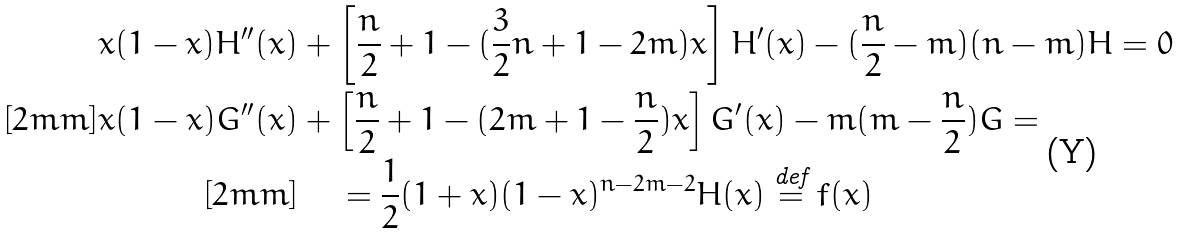Convert formula to latex. <formula><loc_0><loc_0><loc_500><loc_500>x ( 1 - x ) H ^ { \prime \prime } ( x ) & + \left [ \frac { n } { 2 } + 1 - ( \frac { 3 } { 2 } n + 1 - 2 m ) x \right ] H ^ { \prime } ( x ) - ( \frac { n } { 2 } - m ) ( n - m ) H = 0 \\ [ 2 m m ] x ( 1 - x ) G ^ { \prime \prime } ( x ) & + \left [ \frac { n } { 2 } + 1 - ( 2 m + 1 - \frac { n } { 2 } ) x \right ] G ^ { \prime } ( x ) - m ( m - \frac { n } { 2 } ) G = \\ [ 2 m m ] & \quad = \frac { 1 } { 2 } ( 1 + x ) ( 1 - x ) ^ { n - 2 m - 2 } H ( x ) \stackrel { \text {def} } { = } f ( x )</formula> 